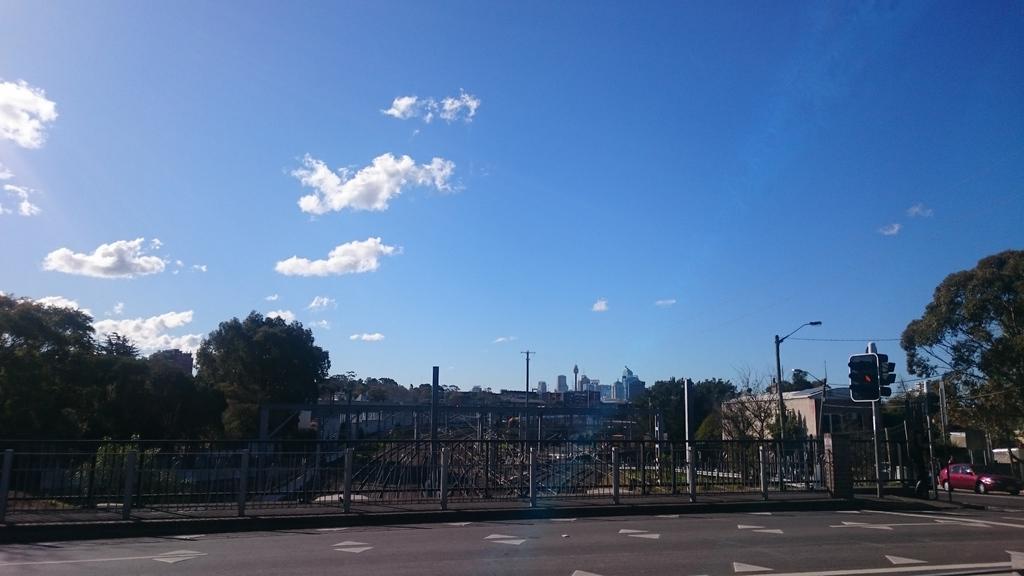Could you give a brief overview of what you see in this image? In this image we can see the fencing. Behind the fencing we can see a poles, trees and buildings. On the right side, we can see the traffic signal and a car. At the top we can see the sky. 